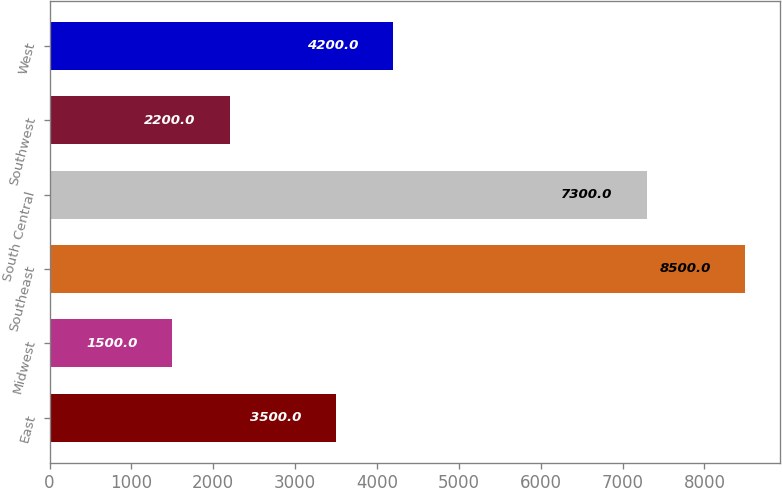Convert chart. <chart><loc_0><loc_0><loc_500><loc_500><bar_chart><fcel>East<fcel>Midwest<fcel>Southeast<fcel>South Central<fcel>Southwest<fcel>West<nl><fcel>3500<fcel>1500<fcel>8500<fcel>7300<fcel>2200<fcel>4200<nl></chart> 